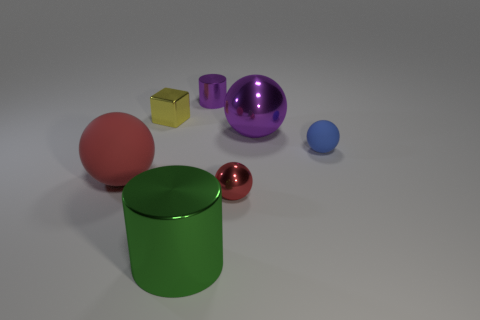Is there a rubber cylinder that has the same color as the tiny shiny sphere?
Make the answer very short. No. Are any small brown objects visible?
Provide a short and direct response. No. What shape is the purple object that is to the left of the large purple metal thing?
Make the answer very short. Cylinder. What number of objects are in front of the small block and right of the yellow shiny thing?
Your answer should be compact. 4. How many other things are there of the same size as the red metal thing?
Provide a short and direct response. 3. There is a red thing behind the small red metallic thing; is its shape the same as the blue thing that is behind the big red rubber object?
Offer a terse response. Yes. How many objects are tiny brown matte cubes or matte things that are to the left of the large purple sphere?
Offer a very short reply. 1. There is a small thing that is left of the blue matte ball and in front of the big purple ball; what is its material?
Your answer should be compact. Metal. Is there any other thing that is the same shape as the small red object?
Keep it short and to the point. Yes. There is a big object that is made of the same material as the small blue ball; what color is it?
Make the answer very short. Red. 